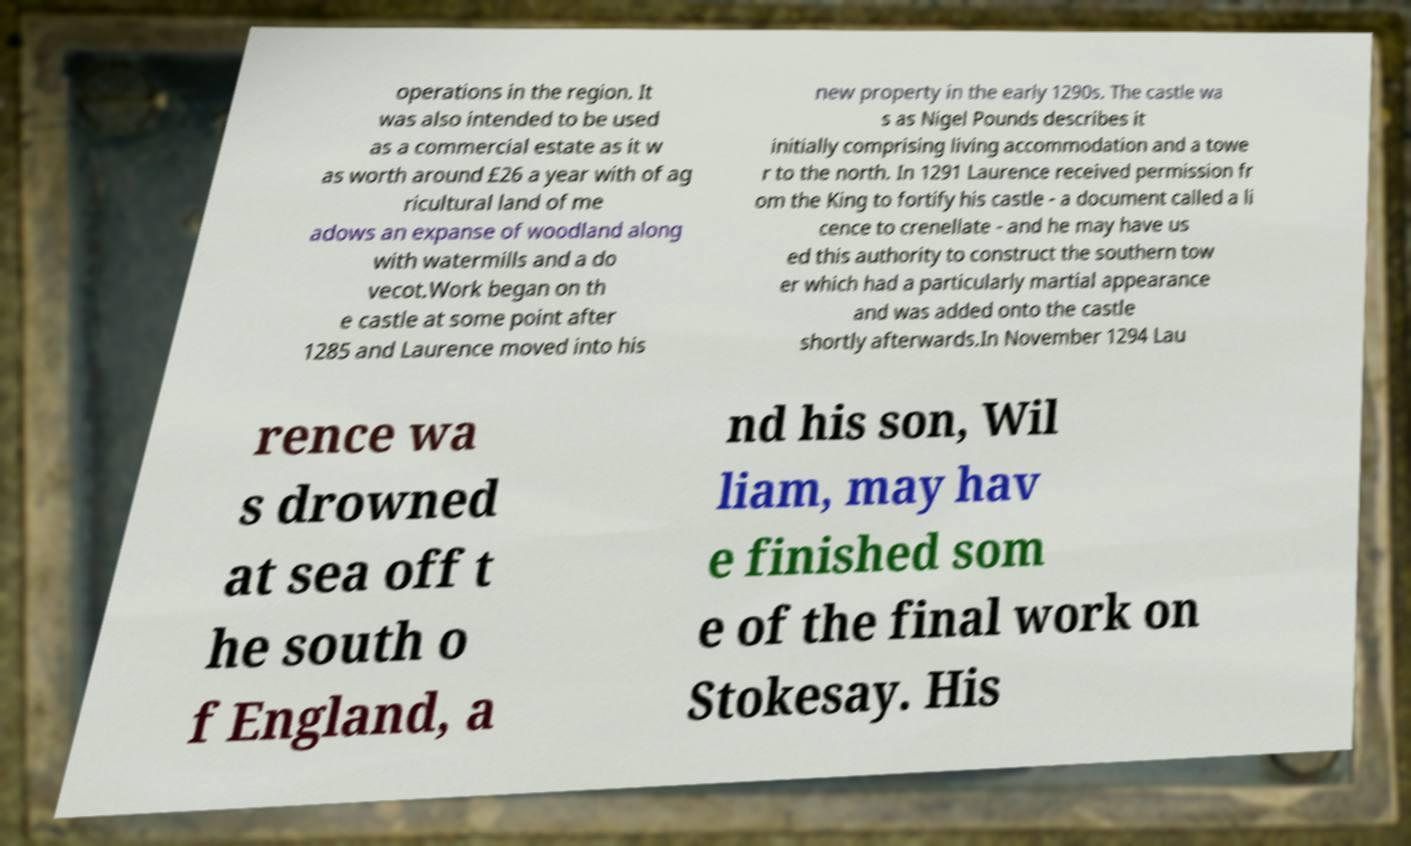There's text embedded in this image that I need extracted. Can you transcribe it verbatim? operations in the region. It was also intended to be used as a commercial estate as it w as worth around £26 a year with of ag ricultural land of me adows an expanse of woodland along with watermills and a do vecot.Work began on th e castle at some point after 1285 and Laurence moved into his new property in the early 1290s. The castle wa s as Nigel Pounds describes it initially comprising living accommodation and a towe r to the north. In 1291 Laurence received permission fr om the King to fortify his castle - a document called a li cence to crenellate - and he may have us ed this authority to construct the southern tow er which had a particularly martial appearance and was added onto the castle shortly afterwards.In November 1294 Lau rence wa s drowned at sea off t he south o f England, a nd his son, Wil liam, may hav e finished som e of the final work on Stokesay. His 